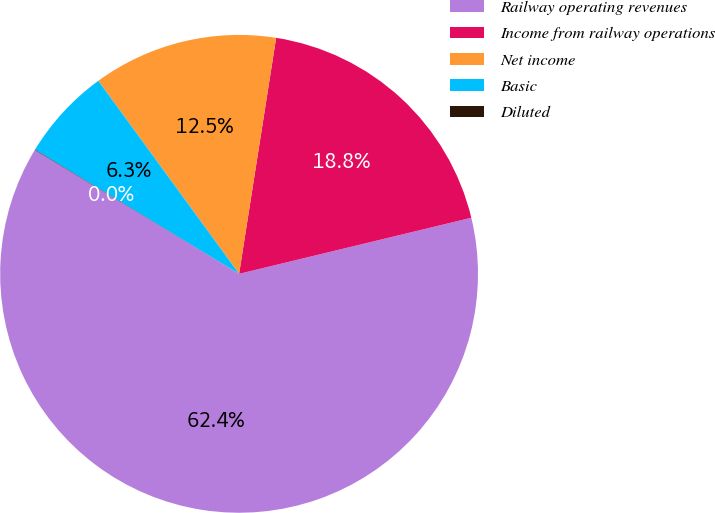<chart> <loc_0><loc_0><loc_500><loc_500><pie_chart><fcel>Railway operating revenues<fcel>Income from railway operations<fcel>Net income<fcel>Basic<fcel>Diluted<nl><fcel>62.44%<fcel>18.75%<fcel>12.51%<fcel>6.27%<fcel>0.03%<nl></chart> 